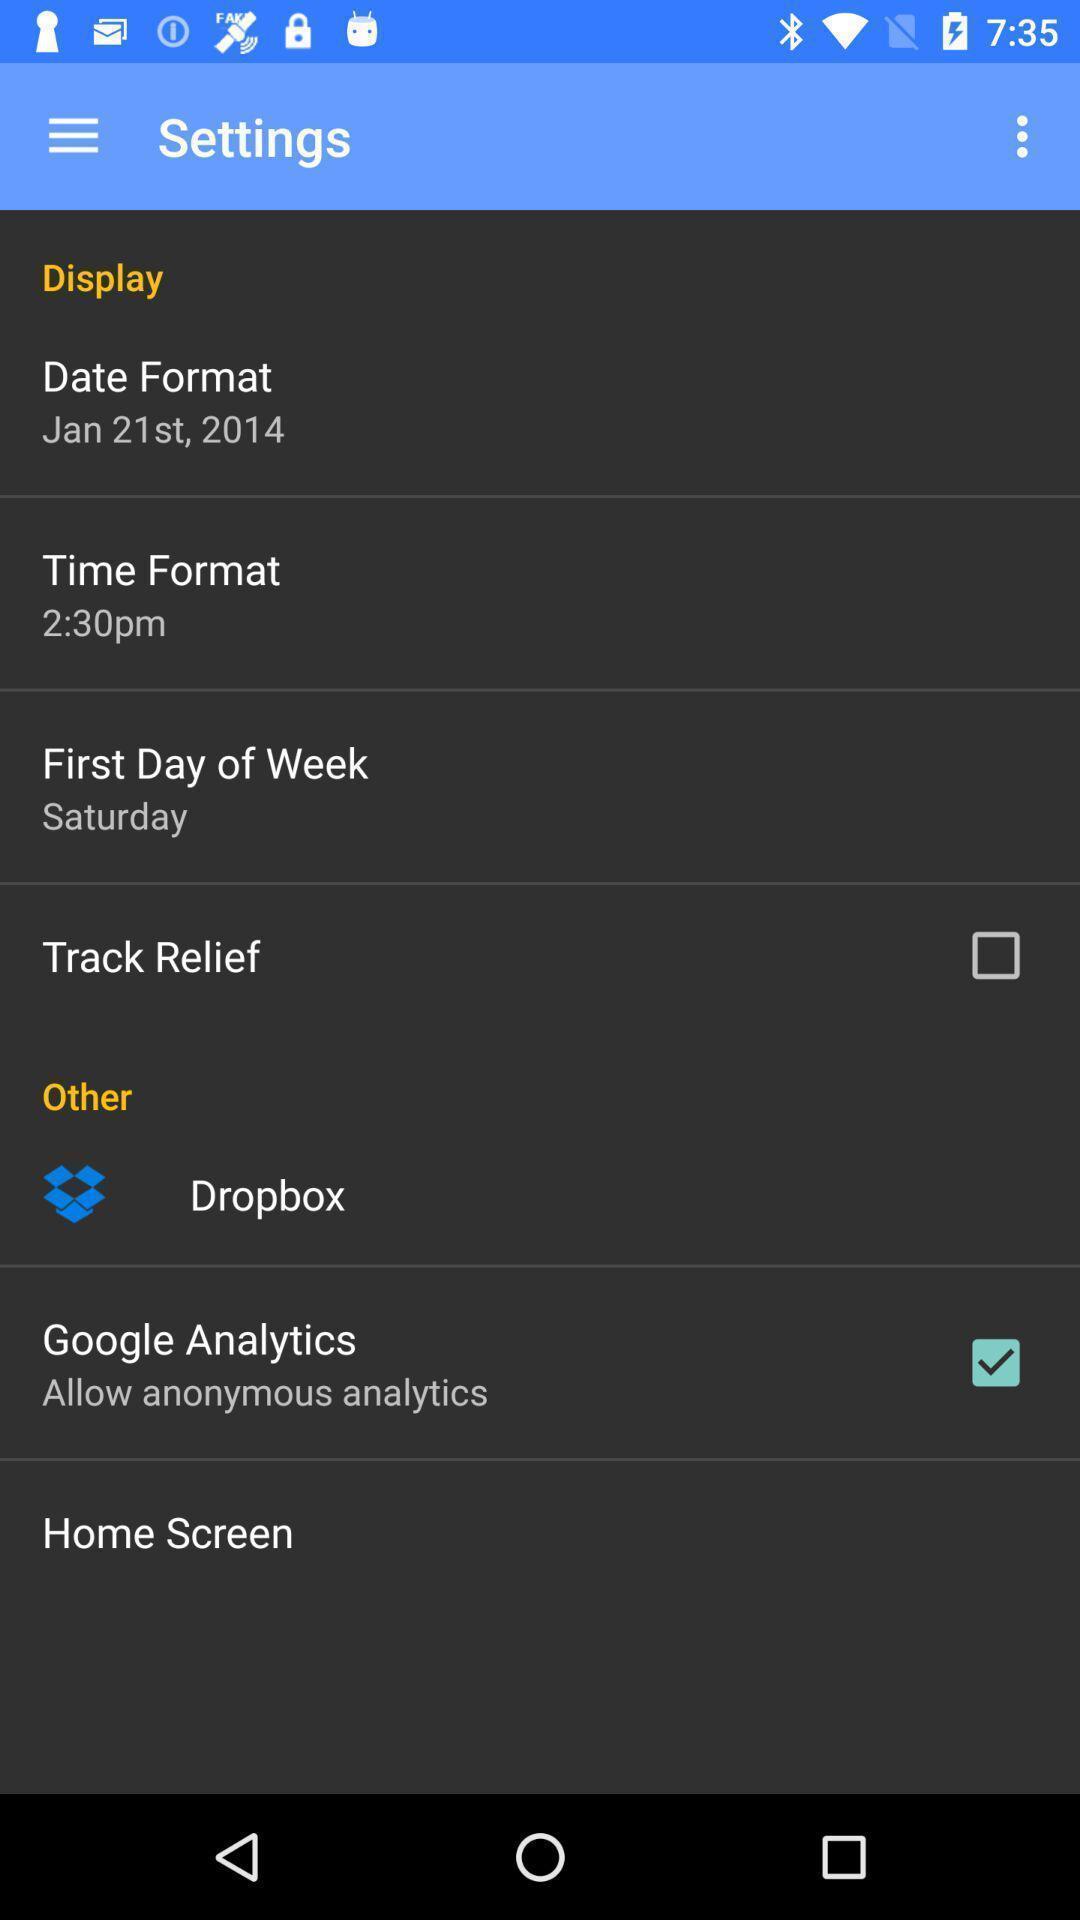What can you discern from this picture? Settings page of a track of headaches app. 